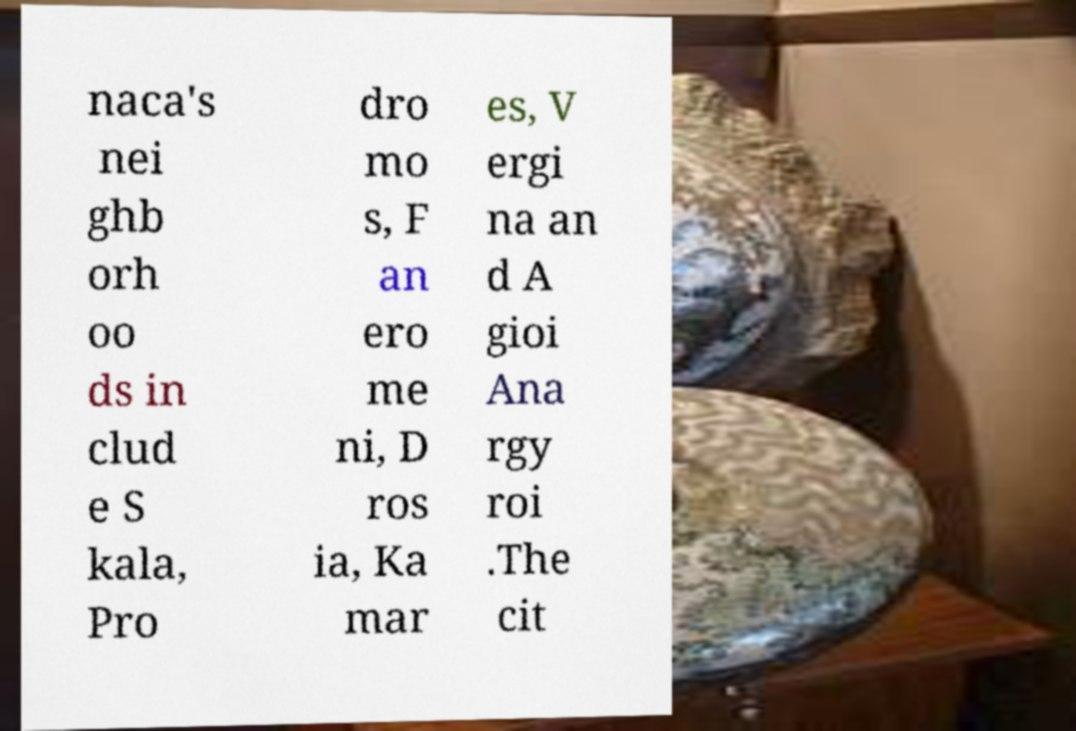Please read and relay the text visible in this image. What does it say? naca's nei ghb orh oo ds in clud e S kala, Pro dro mo s, F an ero me ni, D ros ia, Ka mar es, V ergi na an d A gioi Ana rgy roi .The cit 